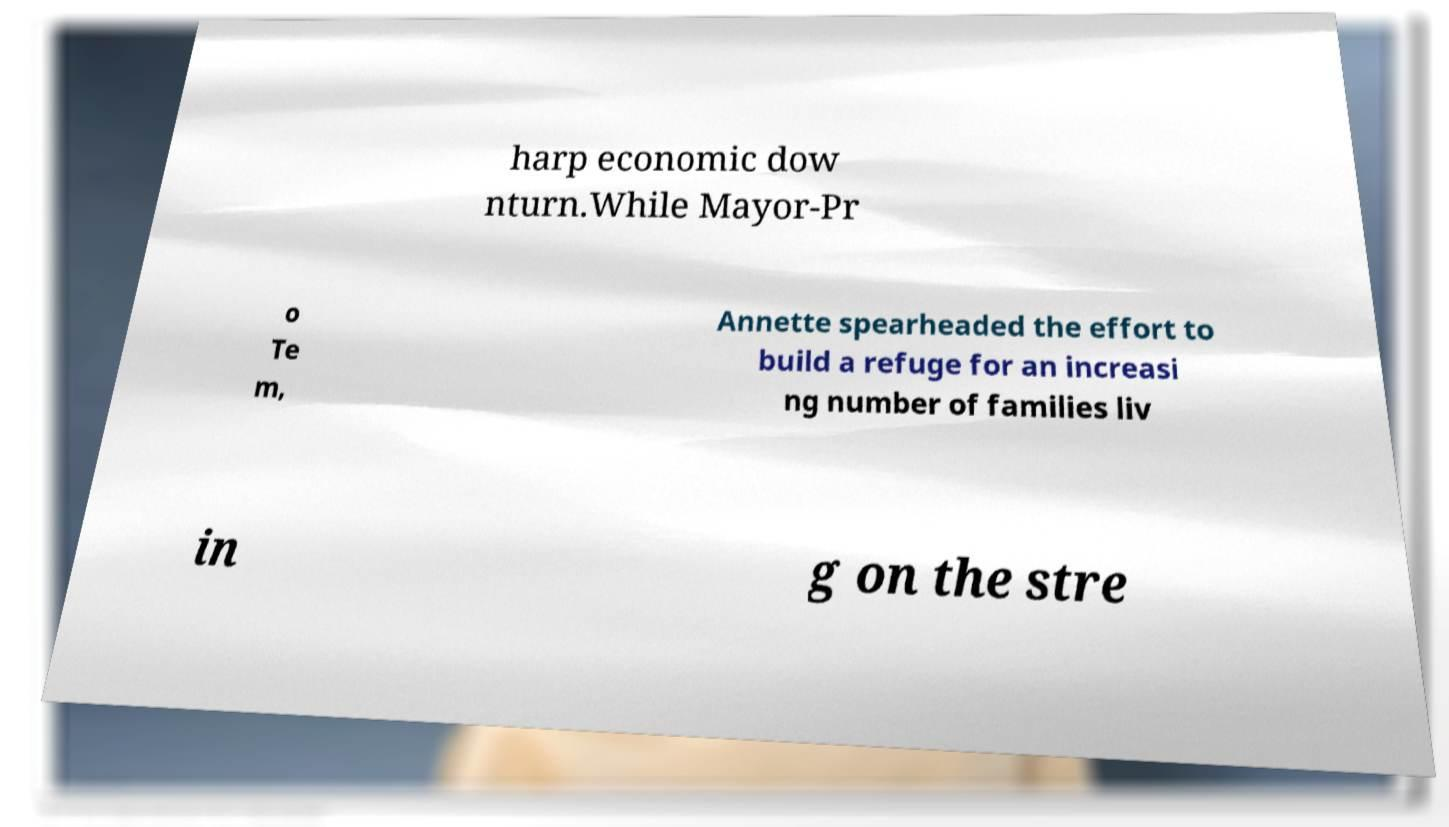I need the written content from this picture converted into text. Can you do that? harp economic dow nturn.While Mayor-Pr o Te m, Annette spearheaded the effort to build a refuge for an increasi ng number of families liv in g on the stre 